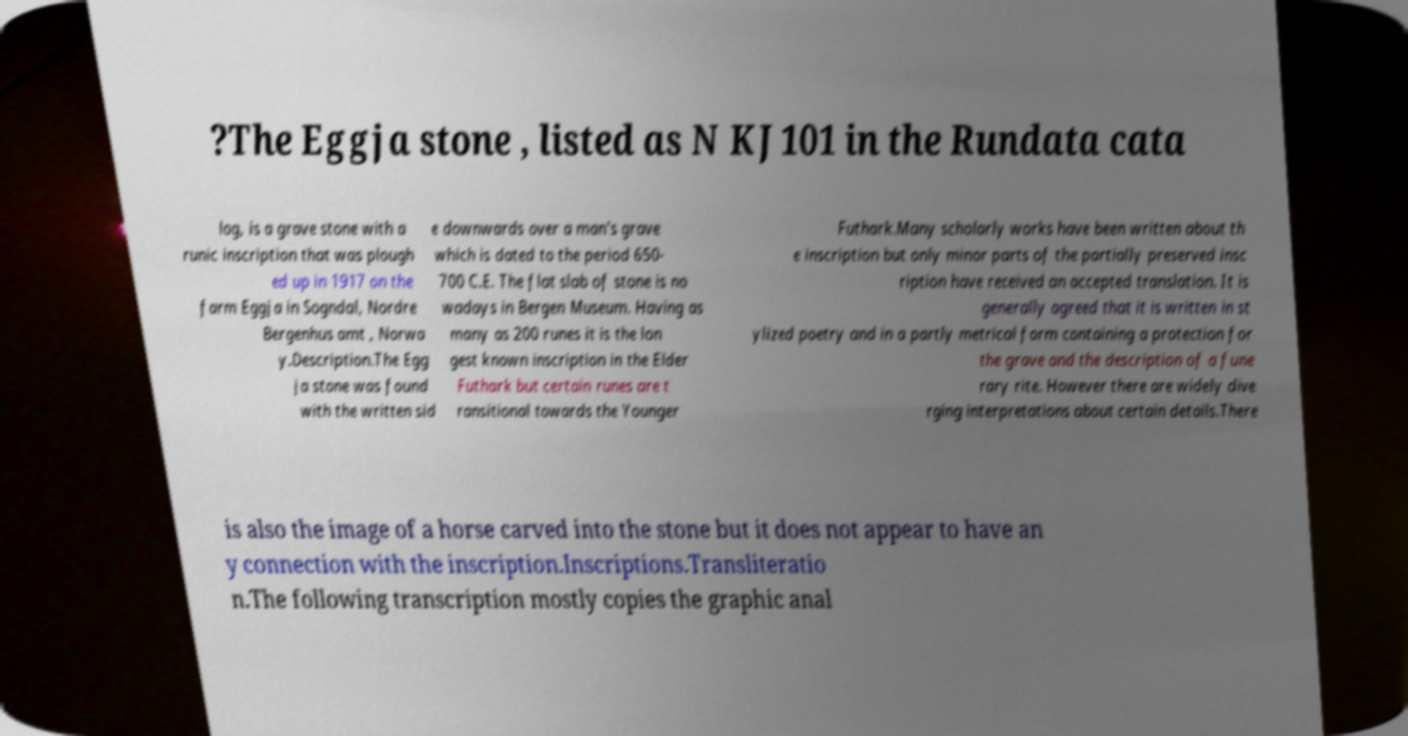Please read and relay the text visible in this image. What does it say? ?The Eggja stone , listed as N KJ101 in the Rundata cata log, is a grave stone with a runic inscription that was plough ed up in 1917 on the farm Eggja in Sogndal, Nordre Bergenhus amt , Norwa y.Description.The Egg ja stone was found with the written sid e downwards over a man's grave which is dated to the period 650- 700 C.E. The flat slab of stone is no wadays in Bergen Museum. Having as many as 200 runes it is the lon gest known inscription in the Elder Futhark but certain runes are t ransitional towards the Younger Futhark.Many scholarly works have been written about th e inscription but only minor parts of the partially preserved insc ription have received an accepted translation. It is generally agreed that it is written in st ylized poetry and in a partly metrical form containing a protection for the grave and the description of a fune rary rite. However there are widely dive rging interpretations about certain details.There is also the image of a horse carved into the stone but it does not appear to have an y connection with the inscription.Inscriptions.Transliteratio n.The following transcription mostly copies the graphic anal 